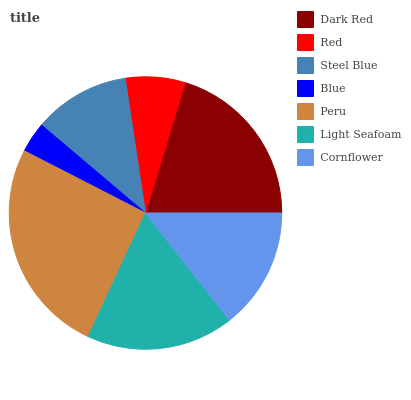Is Blue the minimum?
Answer yes or no. Yes. Is Peru the maximum?
Answer yes or no. Yes. Is Red the minimum?
Answer yes or no. No. Is Red the maximum?
Answer yes or no. No. Is Dark Red greater than Red?
Answer yes or no. Yes. Is Red less than Dark Red?
Answer yes or no. Yes. Is Red greater than Dark Red?
Answer yes or no. No. Is Dark Red less than Red?
Answer yes or no. No. Is Cornflower the high median?
Answer yes or no. Yes. Is Cornflower the low median?
Answer yes or no. Yes. Is Peru the high median?
Answer yes or no. No. Is Peru the low median?
Answer yes or no. No. 